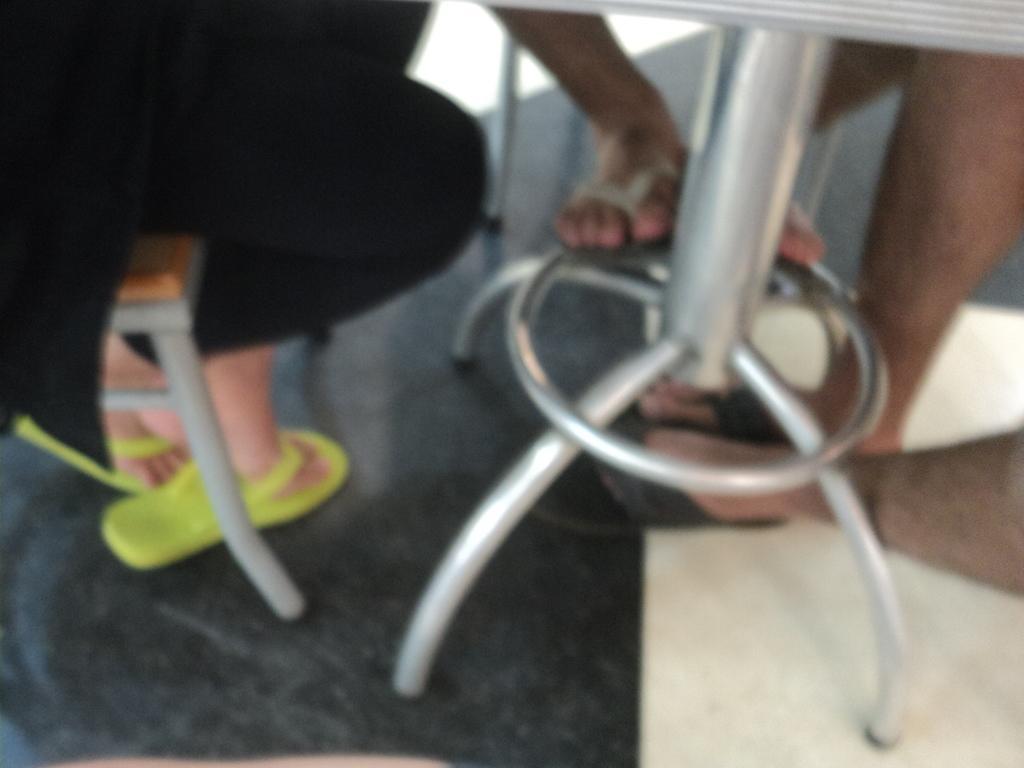Can you describe this image briefly? In this image, we can see persons sitting on chairs in front of the table. 